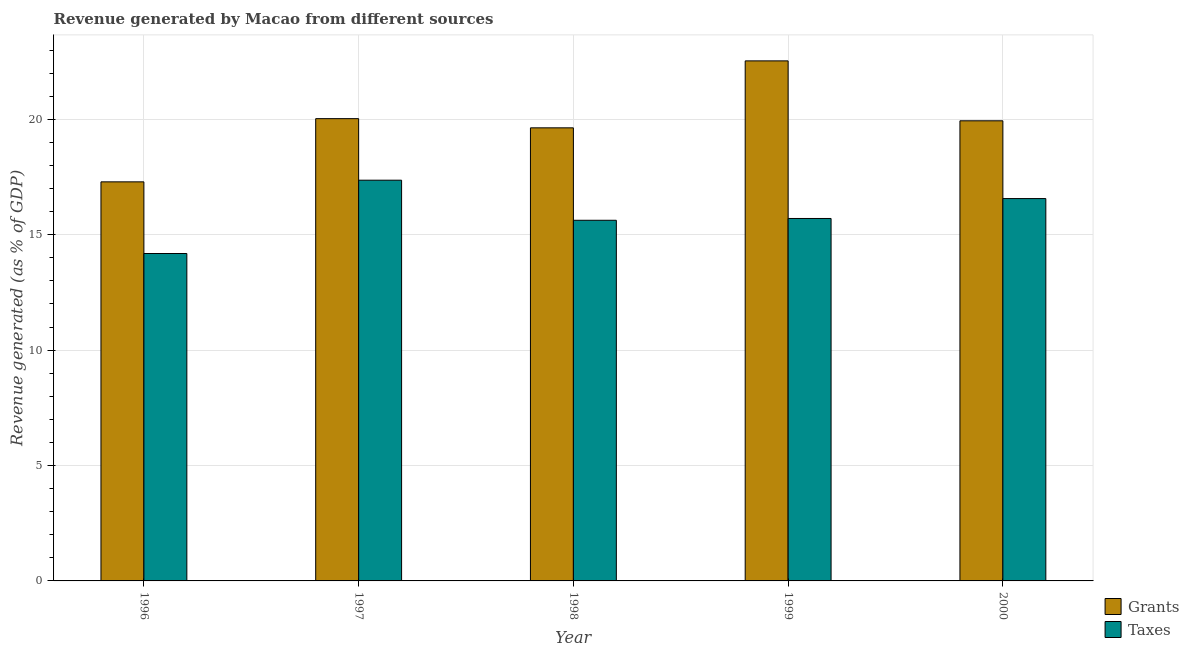How many different coloured bars are there?
Your response must be concise. 2. How many groups of bars are there?
Offer a very short reply. 5. Are the number of bars per tick equal to the number of legend labels?
Your answer should be very brief. Yes. Are the number of bars on each tick of the X-axis equal?
Make the answer very short. Yes. How many bars are there on the 3rd tick from the right?
Make the answer very short. 2. What is the revenue generated by taxes in 1998?
Offer a very short reply. 15.63. Across all years, what is the maximum revenue generated by taxes?
Offer a terse response. 17.36. Across all years, what is the minimum revenue generated by taxes?
Give a very brief answer. 14.19. In which year was the revenue generated by taxes maximum?
Ensure brevity in your answer.  1997. What is the total revenue generated by grants in the graph?
Offer a very short reply. 99.43. What is the difference between the revenue generated by taxes in 1997 and that in 1998?
Offer a terse response. 1.74. What is the difference between the revenue generated by grants in 1997 and the revenue generated by taxes in 1999?
Your response must be concise. -2.5. What is the average revenue generated by taxes per year?
Keep it short and to the point. 15.89. What is the ratio of the revenue generated by taxes in 1998 to that in 2000?
Your answer should be very brief. 0.94. Is the difference between the revenue generated by taxes in 1996 and 1998 greater than the difference between the revenue generated by grants in 1996 and 1998?
Provide a succinct answer. No. What is the difference between the highest and the second highest revenue generated by grants?
Make the answer very short. 2.5. What is the difference between the highest and the lowest revenue generated by taxes?
Keep it short and to the point. 3.18. In how many years, is the revenue generated by taxes greater than the average revenue generated by taxes taken over all years?
Ensure brevity in your answer.  2. Is the sum of the revenue generated by taxes in 1996 and 2000 greater than the maximum revenue generated by grants across all years?
Your response must be concise. Yes. What does the 1st bar from the left in 1997 represents?
Keep it short and to the point. Grants. What does the 1st bar from the right in 1999 represents?
Give a very brief answer. Taxes. How many bars are there?
Keep it short and to the point. 10. Are all the bars in the graph horizontal?
Your answer should be very brief. No. How many years are there in the graph?
Give a very brief answer. 5. Are the values on the major ticks of Y-axis written in scientific E-notation?
Offer a very short reply. No. Does the graph contain grids?
Your response must be concise. Yes. Where does the legend appear in the graph?
Ensure brevity in your answer.  Bottom right. How many legend labels are there?
Make the answer very short. 2. What is the title of the graph?
Provide a short and direct response. Revenue generated by Macao from different sources. Does "Domestic Liabilities" appear as one of the legend labels in the graph?
Provide a short and direct response. No. What is the label or title of the Y-axis?
Offer a very short reply. Revenue generated (as % of GDP). What is the Revenue generated (as % of GDP) of Grants in 1996?
Your response must be concise. 17.29. What is the Revenue generated (as % of GDP) in Taxes in 1996?
Keep it short and to the point. 14.19. What is the Revenue generated (as % of GDP) of Grants in 1997?
Offer a terse response. 20.03. What is the Revenue generated (as % of GDP) in Taxes in 1997?
Offer a very short reply. 17.36. What is the Revenue generated (as % of GDP) in Grants in 1998?
Your response must be concise. 19.63. What is the Revenue generated (as % of GDP) in Taxes in 1998?
Offer a very short reply. 15.63. What is the Revenue generated (as % of GDP) in Grants in 1999?
Provide a succinct answer. 22.53. What is the Revenue generated (as % of GDP) in Taxes in 1999?
Your answer should be compact. 15.71. What is the Revenue generated (as % of GDP) in Grants in 2000?
Give a very brief answer. 19.94. What is the Revenue generated (as % of GDP) of Taxes in 2000?
Offer a terse response. 16.57. Across all years, what is the maximum Revenue generated (as % of GDP) in Grants?
Your response must be concise. 22.53. Across all years, what is the maximum Revenue generated (as % of GDP) in Taxes?
Keep it short and to the point. 17.36. Across all years, what is the minimum Revenue generated (as % of GDP) of Grants?
Your answer should be very brief. 17.29. Across all years, what is the minimum Revenue generated (as % of GDP) in Taxes?
Give a very brief answer. 14.19. What is the total Revenue generated (as % of GDP) in Grants in the graph?
Provide a succinct answer. 99.43. What is the total Revenue generated (as % of GDP) of Taxes in the graph?
Your answer should be compact. 79.45. What is the difference between the Revenue generated (as % of GDP) in Grants in 1996 and that in 1997?
Ensure brevity in your answer.  -2.74. What is the difference between the Revenue generated (as % of GDP) in Taxes in 1996 and that in 1997?
Your answer should be compact. -3.18. What is the difference between the Revenue generated (as % of GDP) in Grants in 1996 and that in 1998?
Your answer should be compact. -2.34. What is the difference between the Revenue generated (as % of GDP) in Taxes in 1996 and that in 1998?
Offer a terse response. -1.44. What is the difference between the Revenue generated (as % of GDP) in Grants in 1996 and that in 1999?
Make the answer very short. -5.24. What is the difference between the Revenue generated (as % of GDP) of Taxes in 1996 and that in 1999?
Provide a short and direct response. -1.52. What is the difference between the Revenue generated (as % of GDP) of Grants in 1996 and that in 2000?
Give a very brief answer. -2.65. What is the difference between the Revenue generated (as % of GDP) of Taxes in 1996 and that in 2000?
Your response must be concise. -2.38. What is the difference between the Revenue generated (as % of GDP) of Grants in 1997 and that in 1998?
Your answer should be very brief. 0.4. What is the difference between the Revenue generated (as % of GDP) in Taxes in 1997 and that in 1998?
Your answer should be compact. 1.74. What is the difference between the Revenue generated (as % of GDP) of Grants in 1997 and that in 1999?
Make the answer very short. -2.5. What is the difference between the Revenue generated (as % of GDP) of Taxes in 1997 and that in 1999?
Your answer should be very brief. 1.66. What is the difference between the Revenue generated (as % of GDP) of Grants in 1997 and that in 2000?
Keep it short and to the point. 0.09. What is the difference between the Revenue generated (as % of GDP) of Taxes in 1997 and that in 2000?
Offer a terse response. 0.8. What is the difference between the Revenue generated (as % of GDP) of Grants in 1998 and that in 1999?
Give a very brief answer. -2.9. What is the difference between the Revenue generated (as % of GDP) of Taxes in 1998 and that in 1999?
Make the answer very short. -0.08. What is the difference between the Revenue generated (as % of GDP) of Grants in 1998 and that in 2000?
Your answer should be compact. -0.3. What is the difference between the Revenue generated (as % of GDP) in Taxes in 1998 and that in 2000?
Give a very brief answer. -0.94. What is the difference between the Revenue generated (as % of GDP) in Grants in 1999 and that in 2000?
Offer a terse response. 2.6. What is the difference between the Revenue generated (as % of GDP) in Taxes in 1999 and that in 2000?
Offer a terse response. -0.86. What is the difference between the Revenue generated (as % of GDP) in Grants in 1996 and the Revenue generated (as % of GDP) in Taxes in 1997?
Your answer should be very brief. -0.07. What is the difference between the Revenue generated (as % of GDP) in Grants in 1996 and the Revenue generated (as % of GDP) in Taxes in 1998?
Ensure brevity in your answer.  1.67. What is the difference between the Revenue generated (as % of GDP) in Grants in 1996 and the Revenue generated (as % of GDP) in Taxes in 1999?
Your answer should be very brief. 1.59. What is the difference between the Revenue generated (as % of GDP) of Grants in 1996 and the Revenue generated (as % of GDP) of Taxes in 2000?
Offer a very short reply. 0.72. What is the difference between the Revenue generated (as % of GDP) of Grants in 1997 and the Revenue generated (as % of GDP) of Taxes in 1998?
Ensure brevity in your answer.  4.4. What is the difference between the Revenue generated (as % of GDP) in Grants in 1997 and the Revenue generated (as % of GDP) in Taxes in 1999?
Make the answer very short. 4.33. What is the difference between the Revenue generated (as % of GDP) in Grants in 1997 and the Revenue generated (as % of GDP) in Taxes in 2000?
Your answer should be very brief. 3.46. What is the difference between the Revenue generated (as % of GDP) in Grants in 1998 and the Revenue generated (as % of GDP) in Taxes in 1999?
Make the answer very short. 3.93. What is the difference between the Revenue generated (as % of GDP) of Grants in 1998 and the Revenue generated (as % of GDP) of Taxes in 2000?
Offer a terse response. 3.06. What is the difference between the Revenue generated (as % of GDP) in Grants in 1999 and the Revenue generated (as % of GDP) in Taxes in 2000?
Your answer should be compact. 5.97. What is the average Revenue generated (as % of GDP) in Grants per year?
Your answer should be compact. 19.89. What is the average Revenue generated (as % of GDP) of Taxes per year?
Offer a terse response. 15.89. In the year 1996, what is the difference between the Revenue generated (as % of GDP) in Grants and Revenue generated (as % of GDP) in Taxes?
Keep it short and to the point. 3.1. In the year 1997, what is the difference between the Revenue generated (as % of GDP) of Grants and Revenue generated (as % of GDP) of Taxes?
Make the answer very short. 2.67. In the year 1998, what is the difference between the Revenue generated (as % of GDP) in Grants and Revenue generated (as % of GDP) in Taxes?
Offer a terse response. 4.01. In the year 1999, what is the difference between the Revenue generated (as % of GDP) of Grants and Revenue generated (as % of GDP) of Taxes?
Give a very brief answer. 6.83. In the year 2000, what is the difference between the Revenue generated (as % of GDP) of Grants and Revenue generated (as % of GDP) of Taxes?
Provide a short and direct response. 3.37. What is the ratio of the Revenue generated (as % of GDP) of Grants in 1996 to that in 1997?
Give a very brief answer. 0.86. What is the ratio of the Revenue generated (as % of GDP) in Taxes in 1996 to that in 1997?
Give a very brief answer. 0.82. What is the ratio of the Revenue generated (as % of GDP) of Grants in 1996 to that in 1998?
Offer a very short reply. 0.88. What is the ratio of the Revenue generated (as % of GDP) of Taxes in 1996 to that in 1998?
Your answer should be very brief. 0.91. What is the ratio of the Revenue generated (as % of GDP) of Grants in 1996 to that in 1999?
Offer a terse response. 0.77. What is the ratio of the Revenue generated (as % of GDP) of Taxes in 1996 to that in 1999?
Keep it short and to the point. 0.9. What is the ratio of the Revenue generated (as % of GDP) of Grants in 1996 to that in 2000?
Ensure brevity in your answer.  0.87. What is the ratio of the Revenue generated (as % of GDP) in Taxes in 1996 to that in 2000?
Give a very brief answer. 0.86. What is the ratio of the Revenue generated (as % of GDP) in Grants in 1997 to that in 1998?
Your answer should be very brief. 1.02. What is the ratio of the Revenue generated (as % of GDP) in Grants in 1997 to that in 1999?
Keep it short and to the point. 0.89. What is the ratio of the Revenue generated (as % of GDP) in Taxes in 1997 to that in 1999?
Keep it short and to the point. 1.11. What is the ratio of the Revenue generated (as % of GDP) of Grants in 1997 to that in 2000?
Give a very brief answer. 1. What is the ratio of the Revenue generated (as % of GDP) of Taxes in 1997 to that in 2000?
Provide a short and direct response. 1.05. What is the ratio of the Revenue generated (as % of GDP) of Grants in 1998 to that in 1999?
Make the answer very short. 0.87. What is the ratio of the Revenue generated (as % of GDP) in Grants in 1998 to that in 2000?
Provide a succinct answer. 0.98. What is the ratio of the Revenue generated (as % of GDP) of Taxes in 1998 to that in 2000?
Your answer should be compact. 0.94. What is the ratio of the Revenue generated (as % of GDP) in Grants in 1999 to that in 2000?
Keep it short and to the point. 1.13. What is the ratio of the Revenue generated (as % of GDP) in Taxes in 1999 to that in 2000?
Give a very brief answer. 0.95. What is the difference between the highest and the second highest Revenue generated (as % of GDP) of Grants?
Offer a terse response. 2.5. What is the difference between the highest and the second highest Revenue generated (as % of GDP) of Taxes?
Make the answer very short. 0.8. What is the difference between the highest and the lowest Revenue generated (as % of GDP) in Grants?
Your answer should be compact. 5.24. What is the difference between the highest and the lowest Revenue generated (as % of GDP) in Taxes?
Your answer should be very brief. 3.18. 